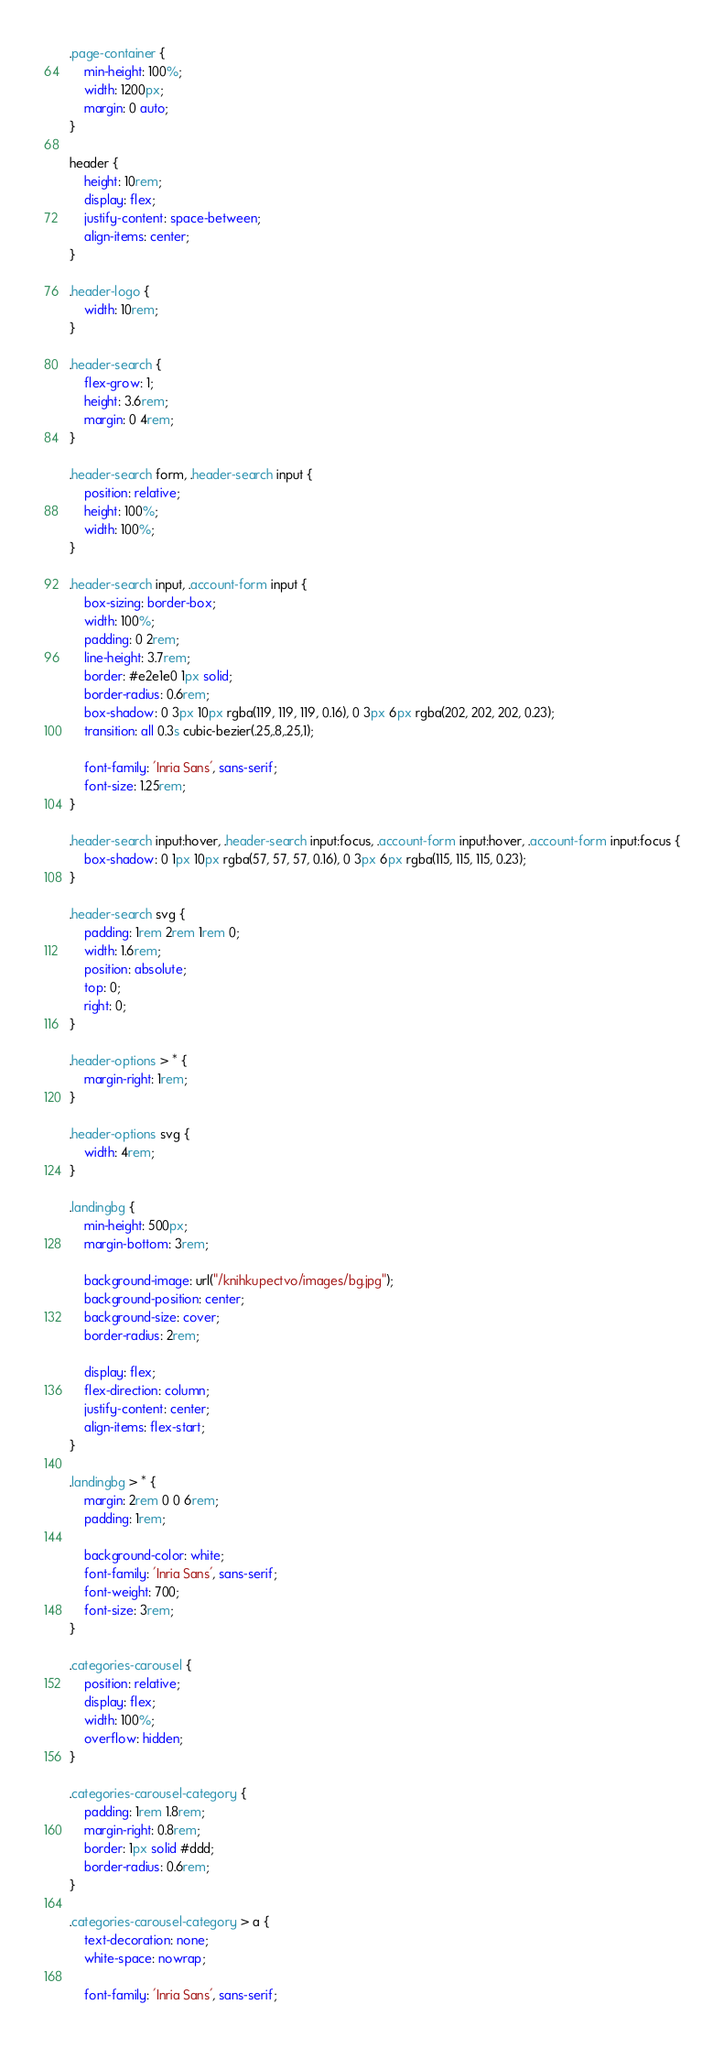<code> <loc_0><loc_0><loc_500><loc_500><_CSS_>.page-container {
    min-height: 100%;
    width: 1200px;
    margin: 0 auto;
}

header {
    height: 10rem;
    display: flex;
    justify-content: space-between;
    align-items: center;
}

.header-logo {
    width: 10rem;
}

.header-search {
    flex-grow: 1;
    height: 3.6rem;
    margin: 0 4rem;
}

.header-search form, .header-search input {
    position: relative;
    height: 100%;
    width: 100%;
}

.header-search input, .account-form input {
    box-sizing: border-box;
    width: 100%;
    padding: 0 2rem;
    line-height: 3.7rem;
    border: #e2e1e0 1px solid;
    border-radius: 0.6rem;
    box-shadow: 0 3px 10px rgba(119, 119, 119, 0.16), 0 3px 6px rgba(202, 202, 202, 0.23);
    transition: all 0.3s cubic-bezier(.25,.8,.25,1);

    font-family: 'Inria Sans', sans-serif;
    font-size: 1.25rem;
}

.header-search input:hover, .header-search input:focus, .account-form input:hover, .account-form input:focus {
    box-shadow: 0 1px 10px rgba(57, 57, 57, 0.16), 0 3px 6px rgba(115, 115, 115, 0.23);
}

.header-search svg {
    padding: 1rem 2rem 1rem 0;
    width: 1.6rem;
    position: absolute;
    top: 0;
    right: 0;
}

.header-options > * {
    margin-right: 1rem;
}

.header-options svg {
    width: 4rem;
}

.landingbg {
    min-height: 500px;
    margin-bottom: 3rem;

    background-image: url("/knihkupectvo/images/bg.jpg");
    background-position: center;
    background-size: cover;
    border-radius: 2rem;

    display: flex;
    flex-direction: column;
    justify-content: center;
    align-items: flex-start;
}

.landingbg > * {
    margin: 2rem 0 0 6rem;
    padding: 1rem;

    background-color: white;
    font-family: 'Inria Sans', sans-serif;
    font-weight: 700;
    font-size: 3rem;
}

.categories-carousel {
    position: relative;
    display: flex;
    width: 100%;
    overflow: hidden;
}

.categories-carousel-category {
    padding: 1rem 1.8rem;
    margin-right: 0.8rem;
    border: 1px solid #ddd;
    border-radius: 0.6rem;
}

.categories-carousel-category > a {
    text-decoration: none;
    white-space: nowrap;

    font-family: 'Inria Sans', sans-serif;</code> 